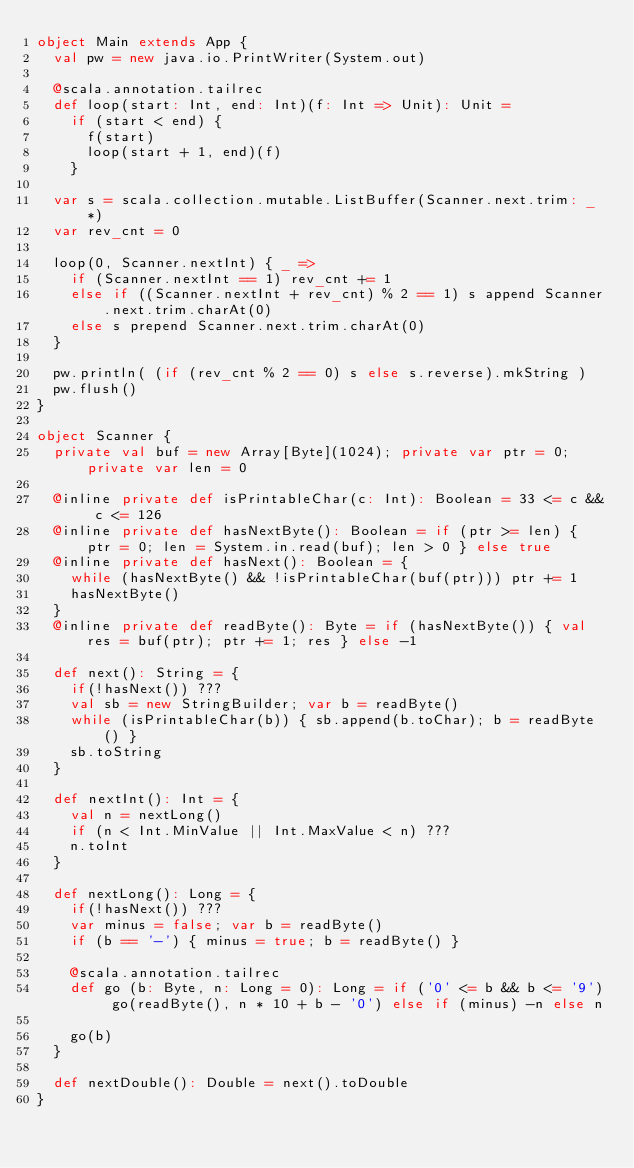Convert code to text. <code><loc_0><loc_0><loc_500><loc_500><_Scala_>object Main extends App {
	val pw = new java.io.PrintWriter(System.out)

	@scala.annotation.tailrec
	def loop(start: Int, end: Int)(f: Int => Unit): Unit =
		if (start < end) {
			f(start)
			loop(start + 1, end)(f)
		}

	var s = scala.collection.mutable.ListBuffer(Scanner.next.trim: _*)
	var rev_cnt = 0

	loop(0, Scanner.nextInt) { _ =>
		if (Scanner.nextInt == 1) rev_cnt += 1
		else if ((Scanner.nextInt + rev_cnt) % 2 == 1) s append Scanner.next.trim.charAt(0)
		else s prepend Scanner.next.trim.charAt(0)
	}

	pw.println( (if (rev_cnt % 2 == 0) s else s.reverse).mkString )
	pw.flush()
}

object Scanner {
	private val buf = new Array[Byte](1024); private var ptr = 0; private var len = 0

	@inline private def isPrintableChar(c: Int): Boolean = 33 <= c && c <= 126
	@inline private def hasNextByte(): Boolean = if (ptr >= len) { ptr = 0; len = System.in.read(buf); len > 0 } else true
	@inline private def hasNext(): Boolean = {
		while (hasNextByte() && !isPrintableChar(buf(ptr))) ptr += 1
		hasNextByte()
	}
	@inline private def readByte(): Byte = if (hasNextByte()) { val res = buf(ptr); ptr += 1; res } else -1

	def next(): String = {
		if(!hasNext()) ???
		val sb = new StringBuilder; var b = readByte()
		while (isPrintableChar(b)) { sb.append(b.toChar); b = readByte() }
		sb.toString
	}

	def nextInt(): Int = {
		val n = nextLong()
		if (n < Int.MinValue || Int.MaxValue < n) ???
		n.toInt
	}

	def nextLong(): Long = {
		if(!hasNext()) ???
		var minus = false; var b = readByte()
		if (b == '-') { minus = true; b = readByte() }

		@scala.annotation.tailrec
		def go (b: Byte, n: Long = 0): Long = if ('0' <= b && b <= '9') go(readByte(), n * 10 + b - '0') else if (minus) -n else n

		go(b)
	}

	def nextDouble(): Double = next().toDouble
}
</code> 